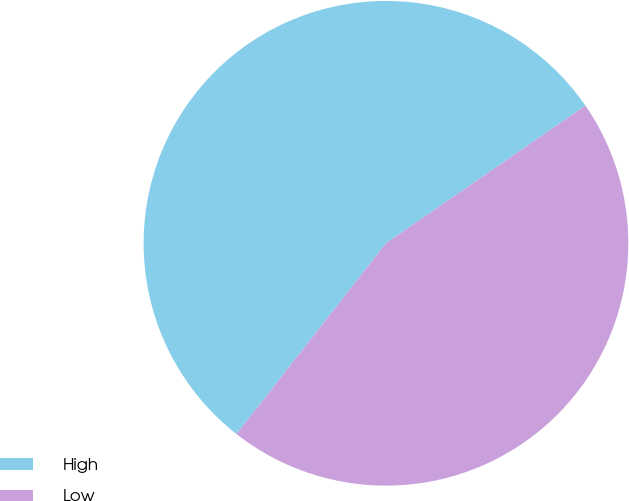Convert chart. <chart><loc_0><loc_0><loc_500><loc_500><pie_chart><fcel>High<fcel>Low<nl><fcel>54.81%<fcel>45.19%<nl></chart> 